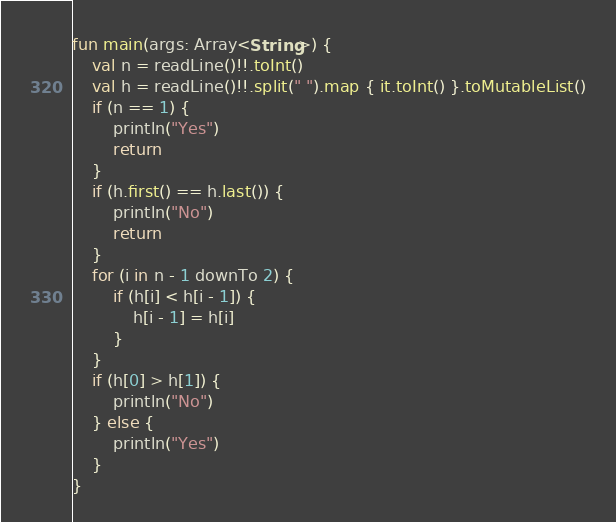<code> <loc_0><loc_0><loc_500><loc_500><_Kotlin_>fun main(args: Array<String>) {
    val n = readLine()!!.toInt()
    val h = readLine()!!.split(" ").map { it.toInt() }.toMutableList()
    if (n == 1) {
        println("Yes")
        return
    }
    if (h.first() == h.last()) {
        println("No")
        return
    }
    for (i in n - 1 downTo 2) {
        if (h[i] < h[i - 1]) {
            h[i - 1] = h[i]
        }
    }
    if (h[0] > h[1]) {
        println("No")
    } else {
        println("Yes")
    }
}</code> 